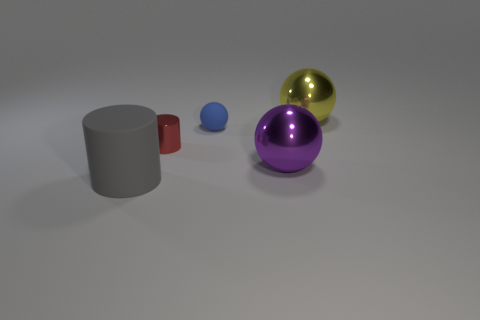Are the large gray object and the big sphere that is in front of the yellow ball made of the same material?
Give a very brief answer. No. There is a big purple object that is the same shape as the yellow thing; what material is it?
Your response must be concise. Metal. Is there any other thing that has the same material as the big gray object?
Your answer should be very brief. Yes. Are the sphere in front of the blue ball and the cylinder that is behind the large gray cylinder made of the same material?
Make the answer very short. Yes. What color is the big shiny thing behind the tiny object that is on the left side of the rubber object that is behind the gray cylinder?
Offer a very short reply. Yellow. How many other objects are the same shape as the large purple metallic thing?
Your answer should be very brief. 2. Is the rubber cylinder the same color as the small matte thing?
Provide a succinct answer. No. How many objects are large purple metal spheres or metal spheres that are on the left side of the large yellow metallic object?
Make the answer very short. 1. Is there another red cylinder that has the same size as the red cylinder?
Ensure brevity in your answer.  No. Does the gray cylinder have the same material as the big purple thing?
Offer a terse response. No. 